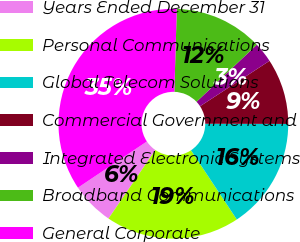Convert chart to OTSL. <chart><loc_0><loc_0><loc_500><loc_500><pie_chart><fcel>Years Ended December 31<fcel>Personal Communications<fcel>Global Telecom Solutions<fcel>Commercial Government and<fcel>Integrated Electronic Systems<fcel>Broadband Communications<fcel>General Corporate<nl><fcel>6.05%<fcel>18.86%<fcel>15.66%<fcel>9.25%<fcel>2.85%<fcel>12.46%<fcel>34.88%<nl></chart> 